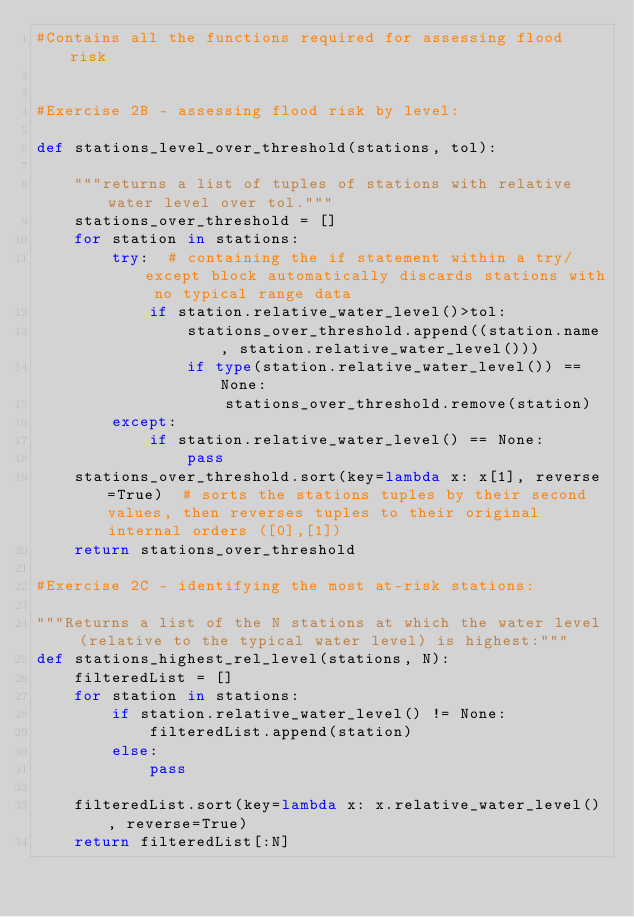Convert code to text. <code><loc_0><loc_0><loc_500><loc_500><_Python_>#Contains all the functions required for assessing flood risk


#Exercise 2B - assessing flood risk by level:

def stations_level_over_threshold(stations, tol):

    """returns a list of tuples of stations with relative water level over tol."""
    stations_over_threshold = []
    for station in stations:
        try:  # containing the if statement within a try/except block automatically discards stations with no typical range data
            if station.relative_water_level()>tol:
                stations_over_threshold.append((station.name, station.relative_water_level()))
                if type(station.relative_water_level()) == None:
                    stations_over_threshold.remove(station)
        except:    
            if station.relative_water_level() == None:
                pass
    stations_over_threshold.sort(key=lambda x: x[1], reverse=True)  # sorts the stations tuples by their second values, then reverses tuples to their original internal orders ([0],[1])
    return stations_over_threshold

#Exercise 2C - identifying the most at-risk stations:

"""Returns a list of the N stations at which the water level (relative to the typical water level) is highest:"""
def stations_highest_rel_level(stations, N):
    filteredList = []
    for station in stations:
        if station.relative_water_level() != None:
            filteredList.append(station)
        else:
            pass

    filteredList.sort(key=lambda x: x.relative_water_level(), reverse=True)
    return filteredList[:N]
</code> 